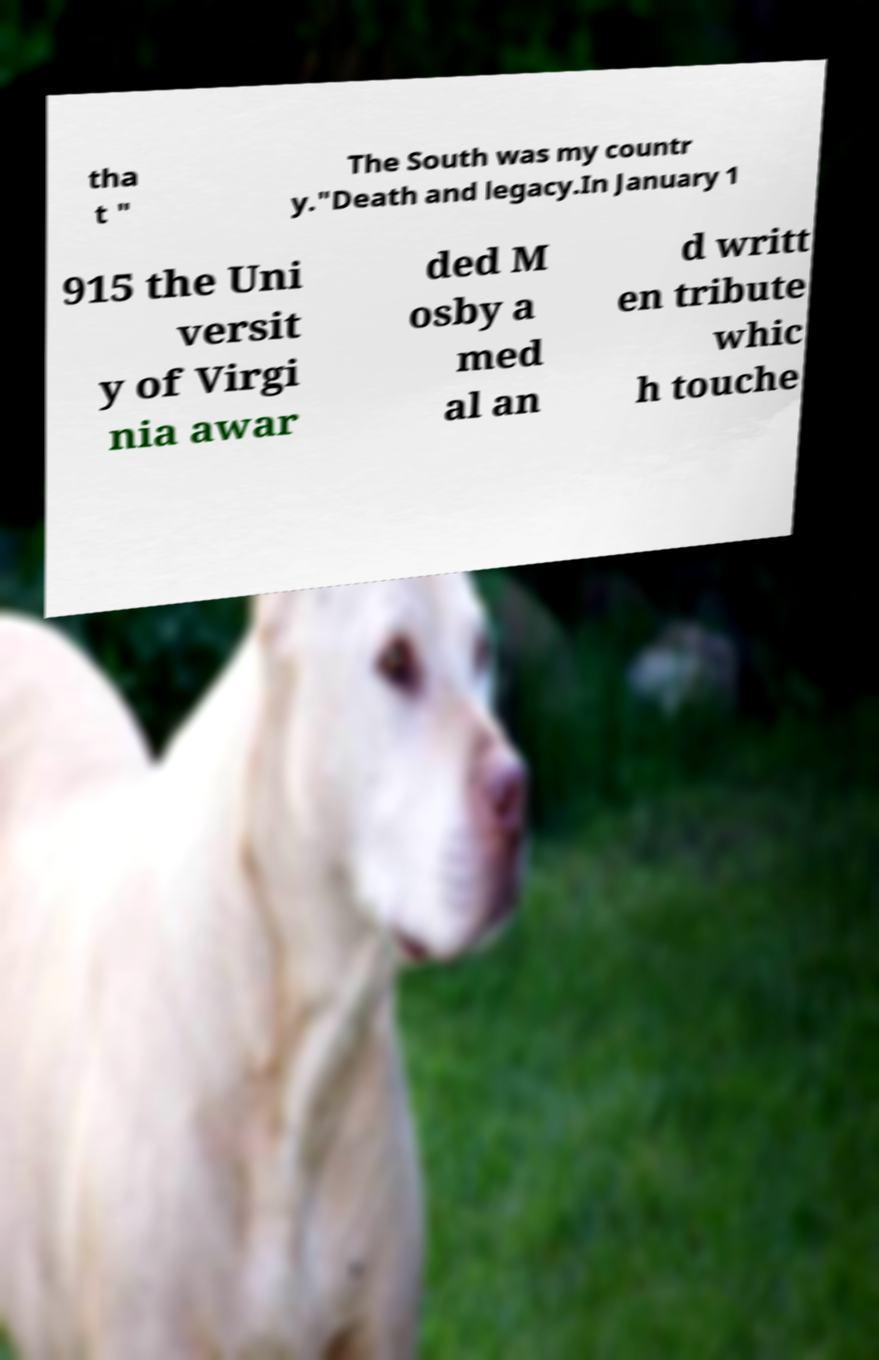There's text embedded in this image that I need extracted. Can you transcribe it verbatim? tha t " The South was my countr y."Death and legacy.In January 1 915 the Uni versit y of Virgi nia awar ded M osby a med al an d writt en tribute whic h touche 